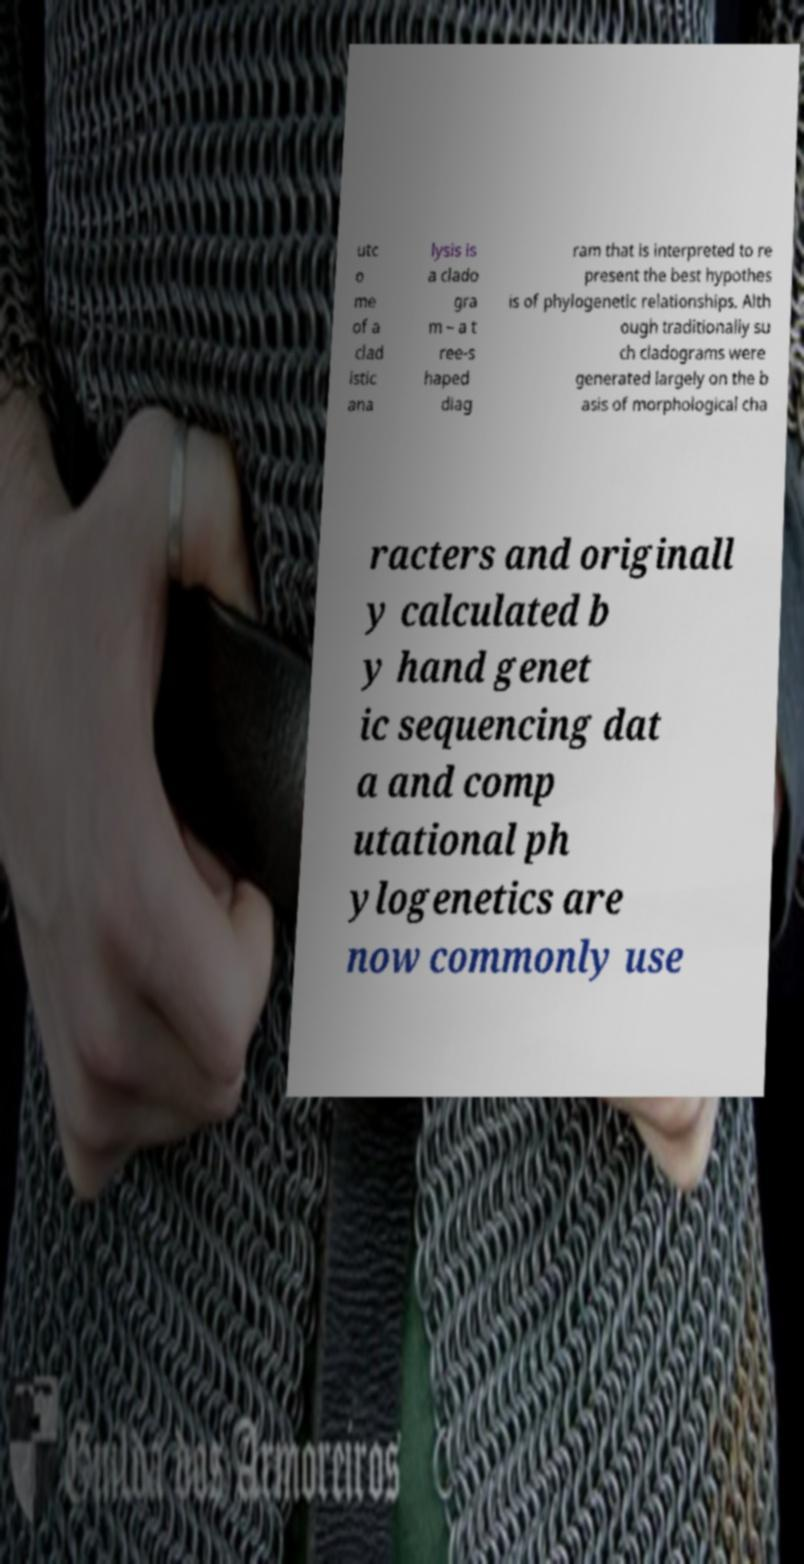There's text embedded in this image that I need extracted. Can you transcribe it verbatim? utc o me of a clad istic ana lysis is a clado gra m – a t ree-s haped diag ram that is interpreted to re present the best hypothes is of phylogenetic relationships. Alth ough traditionally su ch cladograms were generated largely on the b asis of morphological cha racters and originall y calculated b y hand genet ic sequencing dat a and comp utational ph ylogenetics are now commonly use 